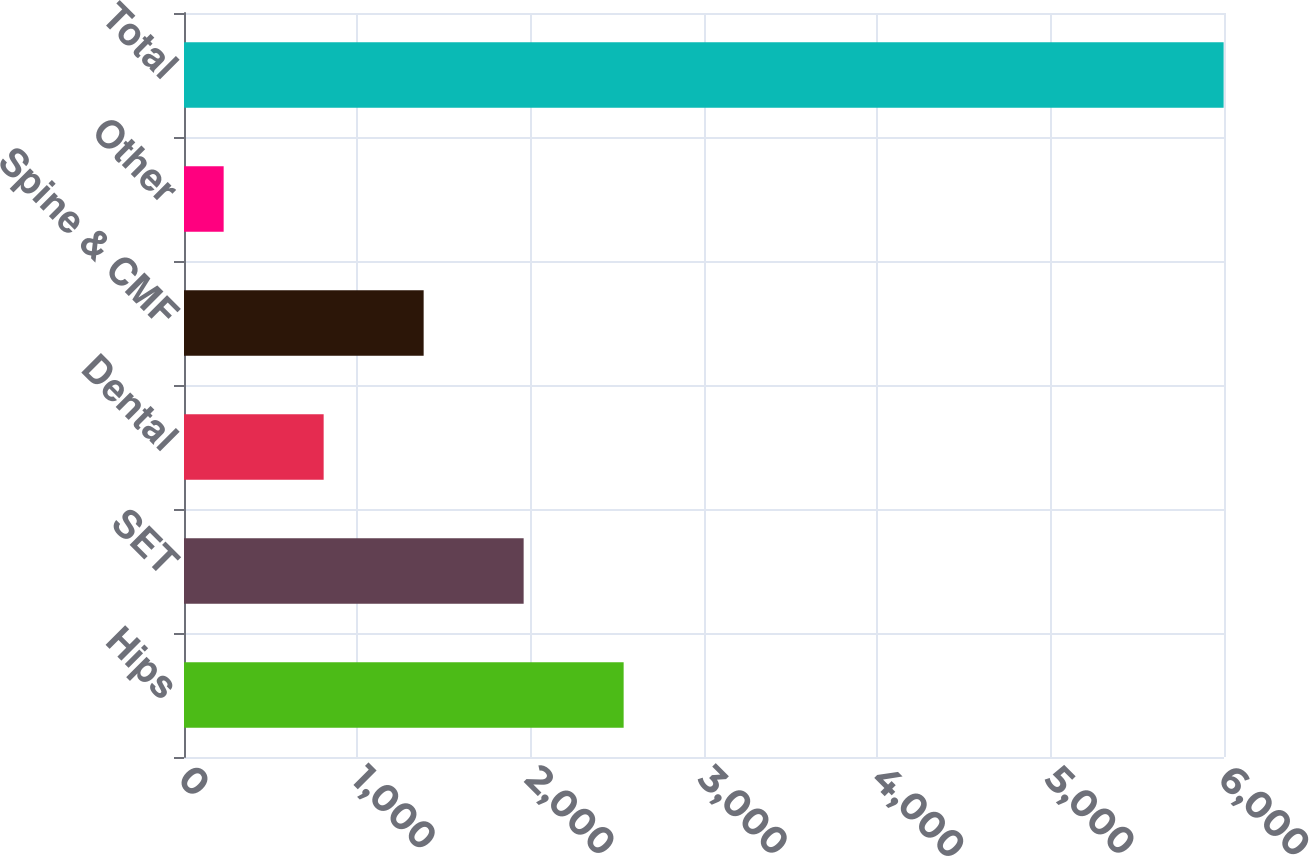Convert chart to OTSL. <chart><loc_0><loc_0><loc_500><loc_500><bar_chart><fcel>Hips<fcel>SET<fcel>Dental<fcel>Spine & CMF<fcel>Other<fcel>Total<nl><fcel>2536.4<fcel>1959.5<fcel>805.7<fcel>1382.6<fcel>228.8<fcel>5997.8<nl></chart> 